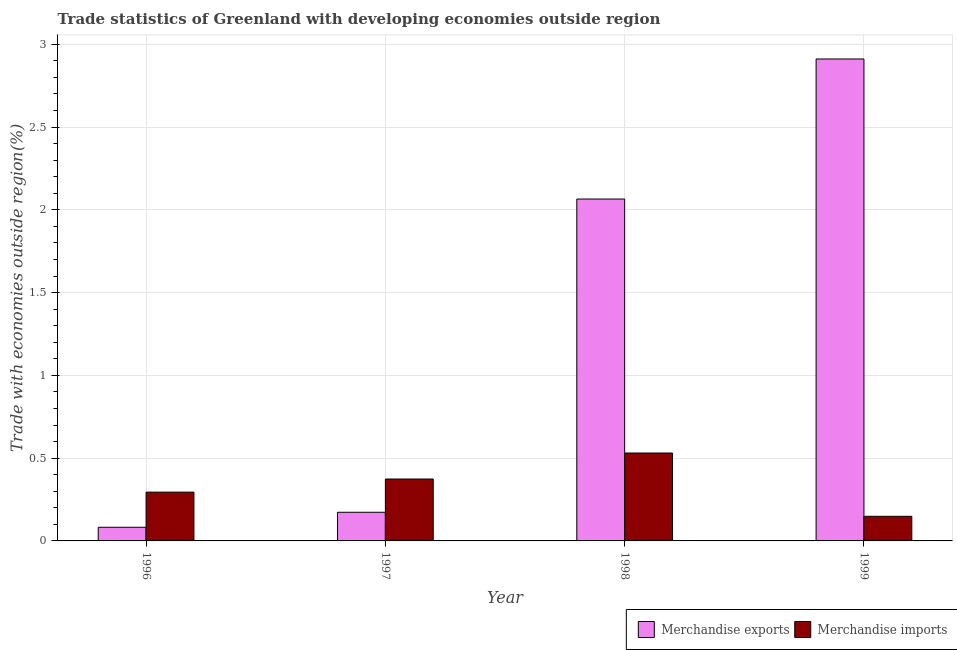How many different coloured bars are there?
Ensure brevity in your answer.  2. How many groups of bars are there?
Offer a terse response. 4. Are the number of bars per tick equal to the number of legend labels?
Make the answer very short. Yes. What is the merchandise imports in 1999?
Offer a very short reply. 0.15. Across all years, what is the maximum merchandise imports?
Give a very brief answer. 0.53. Across all years, what is the minimum merchandise exports?
Make the answer very short. 0.08. What is the total merchandise imports in the graph?
Offer a very short reply. 1.35. What is the difference between the merchandise imports in 1997 and that in 1998?
Make the answer very short. -0.16. What is the difference between the merchandise imports in 1997 and the merchandise exports in 1999?
Keep it short and to the point. 0.23. What is the average merchandise imports per year?
Provide a short and direct response. 0.34. What is the ratio of the merchandise imports in 1997 to that in 1999?
Provide a succinct answer. 2.52. Is the merchandise exports in 1997 less than that in 1999?
Give a very brief answer. Yes. Is the difference between the merchandise exports in 1998 and 1999 greater than the difference between the merchandise imports in 1998 and 1999?
Give a very brief answer. No. What is the difference between the highest and the second highest merchandise exports?
Provide a succinct answer. 0.85. What is the difference between the highest and the lowest merchandise exports?
Make the answer very short. 2.83. In how many years, is the merchandise imports greater than the average merchandise imports taken over all years?
Ensure brevity in your answer.  2. Is the sum of the merchandise exports in 1997 and 1998 greater than the maximum merchandise imports across all years?
Provide a short and direct response. No. How many years are there in the graph?
Your answer should be very brief. 4. Are the values on the major ticks of Y-axis written in scientific E-notation?
Make the answer very short. No. Does the graph contain any zero values?
Ensure brevity in your answer.  No. Does the graph contain grids?
Your answer should be very brief. Yes. Where does the legend appear in the graph?
Give a very brief answer. Bottom right. How many legend labels are there?
Provide a short and direct response. 2. What is the title of the graph?
Your response must be concise. Trade statistics of Greenland with developing economies outside region. What is the label or title of the X-axis?
Offer a terse response. Year. What is the label or title of the Y-axis?
Offer a very short reply. Trade with economies outside region(%). What is the Trade with economies outside region(%) of Merchandise exports in 1996?
Offer a very short reply. 0.08. What is the Trade with economies outside region(%) in Merchandise imports in 1996?
Your answer should be compact. 0.29. What is the Trade with economies outside region(%) of Merchandise exports in 1997?
Your response must be concise. 0.17. What is the Trade with economies outside region(%) in Merchandise imports in 1997?
Your response must be concise. 0.37. What is the Trade with economies outside region(%) in Merchandise exports in 1998?
Provide a short and direct response. 2.07. What is the Trade with economies outside region(%) of Merchandise imports in 1998?
Provide a succinct answer. 0.53. What is the Trade with economies outside region(%) of Merchandise exports in 1999?
Provide a short and direct response. 2.91. What is the Trade with economies outside region(%) of Merchandise imports in 1999?
Your response must be concise. 0.15. Across all years, what is the maximum Trade with economies outside region(%) of Merchandise exports?
Keep it short and to the point. 2.91. Across all years, what is the maximum Trade with economies outside region(%) of Merchandise imports?
Give a very brief answer. 0.53. Across all years, what is the minimum Trade with economies outside region(%) of Merchandise exports?
Provide a short and direct response. 0.08. Across all years, what is the minimum Trade with economies outside region(%) of Merchandise imports?
Offer a very short reply. 0.15. What is the total Trade with economies outside region(%) in Merchandise exports in the graph?
Make the answer very short. 5.23. What is the total Trade with economies outside region(%) in Merchandise imports in the graph?
Provide a succinct answer. 1.35. What is the difference between the Trade with economies outside region(%) of Merchandise exports in 1996 and that in 1997?
Ensure brevity in your answer.  -0.09. What is the difference between the Trade with economies outside region(%) in Merchandise imports in 1996 and that in 1997?
Make the answer very short. -0.08. What is the difference between the Trade with economies outside region(%) of Merchandise exports in 1996 and that in 1998?
Offer a very short reply. -1.98. What is the difference between the Trade with economies outside region(%) of Merchandise imports in 1996 and that in 1998?
Offer a very short reply. -0.24. What is the difference between the Trade with economies outside region(%) in Merchandise exports in 1996 and that in 1999?
Your answer should be very brief. -2.83. What is the difference between the Trade with economies outside region(%) in Merchandise imports in 1996 and that in 1999?
Your answer should be very brief. 0.15. What is the difference between the Trade with economies outside region(%) in Merchandise exports in 1997 and that in 1998?
Offer a terse response. -1.89. What is the difference between the Trade with economies outside region(%) of Merchandise imports in 1997 and that in 1998?
Offer a terse response. -0.16. What is the difference between the Trade with economies outside region(%) in Merchandise exports in 1997 and that in 1999?
Your response must be concise. -2.74. What is the difference between the Trade with economies outside region(%) of Merchandise imports in 1997 and that in 1999?
Provide a short and direct response. 0.23. What is the difference between the Trade with economies outside region(%) of Merchandise exports in 1998 and that in 1999?
Offer a very short reply. -0.85. What is the difference between the Trade with economies outside region(%) in Merchandise imports in 1998 and that in 1999?
Your answer should be very brief. 0.38. What is the difference between the Trade with economies outside region(%) in Merchandise exports in 1996 and the Trade with economies outside region(%) in Merchandise imports in 1997?
Give a very brief answer. -0.29. What is the difference between the Trade with economies outside region(%) in Merchandise exports in 1996 and the Trade with economies outside region(%) in Merchandise imports in 1998?
Offer a very short reply. -0.45. What is the difference between the Trade with economies outside region(%) in Merchandise exports in 1996 and the Trade with economies outside region(%) in Merchandise imports in 1999?
Offer a terse response. -0.07. What is the difference between the Trade with economies outside region(%) in Merchandise exports in 1997 and the Trade with economies outside region(%) in Merchandise imports in 1998?
Your answer should be compact. -0.36. What is the difference between the Trade with economies outside region(%) in Merchandise exports in 1997 and the Trade with economies outside region(%) in Merchandise imports in 1999?
Keep it short and to the point. 0.02. What is the difference between the Trade with economies outside region(%) of Merchandise exports in 1998 and the Trade with economies outside region(%) of Merchandise imports in 1999?
Your response must be concise. 1.92. What is the average Trade with economies outside region(%) of Merchandise exports per year?
Give a very brief answer. 1.31. What is the average Trade with economies outside region(%) of Merchandise imports per year?
Your answer should be compact. 0.34. In the year 1996, what is the difference between the Trade with economies outside region(%) in Merchandise exports and Trade with economies outside region(%) in Merchandise imports?
Ensure brevity in your answer.  -0.21. In the year 1997, what is the difference between the Trade with economies outside region(%) in Merchandise exports and Trade with economies outside region(%) in Merchandise imports?
Make the answer very short. -0.2. In the year 1998, what is the difference between the Trade with economies outside region(%) in Merchandise exports and Trade with economies outside region(%) in Merchandise imports?
Offer a very short reply. 1.53. In the year 1999, what is the difference between the Trade with economies outside region(%) of Merchandise exports and Trade with economies outside region(%) of Merchandise imports?
Your answer should be compact. 2.76. What is the ratio of the Trade with economies outside region(%) in Merchandise exports in 1996 to that in 1997?
Provide a succinct answer. 0.48. What is the ratio of the Trade with economies outside region(%) of Merchandise imports in 1996 to that in 1997?
Your response must be concise. 0.79. What is the ratio of the Trade with economies outside region(%) in Merchandise exports in 1996 to that in 1998?
Offer a terse response. 0.04. What is the ratio of the Trade with economies outside region(%) in Merchandise imports in 1996 to that in 1998?
Offer a very short reply. 0.56. What is the ratio of the Trade with economies outside region(%) of Merchandise exports in 1996 to that in 1999?
Offer a terse response. 0.03. What is the ratio of the Trade with economies outside region(%) of Merchandise imports in 1996 to that in 1999?
Give a very brief answer. 1.98. What is the ratio of the Trade with economies outside region(%) in Merchandise exports in 1997 to that in 1998?
Ensure brevity in your answer.  0.08. What is the ratio of the Trade with economies outside region(%) in Merchandise imports in 1997 to that in 1998?
Your response must be concise. 0.7. What is the ratio of the Trade with economies outside region(%) of Merchandise exports in 1997 to that in 1999?
Offer a terse response. 0.06. What is the ratio of the Trade with economies outside region(%) of Merchandise imports in 1997 to that in 1999?
Provide a short and direct response. 2.52. What is the ratio of the Trade with economies outside region(%) in Merchandise exports in 1998 to that in 1999?
Your answer should be compact. 0.71. What is the ratio of the Trade with economies outside region(%) of Merchandise imports in 1998 to that in 1999?
Provide a short and direct response. 3.57. What is the difference between the highest and the second highest Trade with economies outside region(%) in Merchandise exports?
Offer a very short reply. 0.85. What is the difference between the highest and the second highest Trade with economies outside region(%) in Merchandise imports?
Give a very brief answer. 0.16. What is the difference between the highest and the lowest Trade with economies outside region(%) of Merchandise exports?
Provide a succinct answer. 2.83. What is the difference between the highest and the lowest Trade with economies outside region(%) of Merchandise imports?
Make the answer very short. 0.38. 